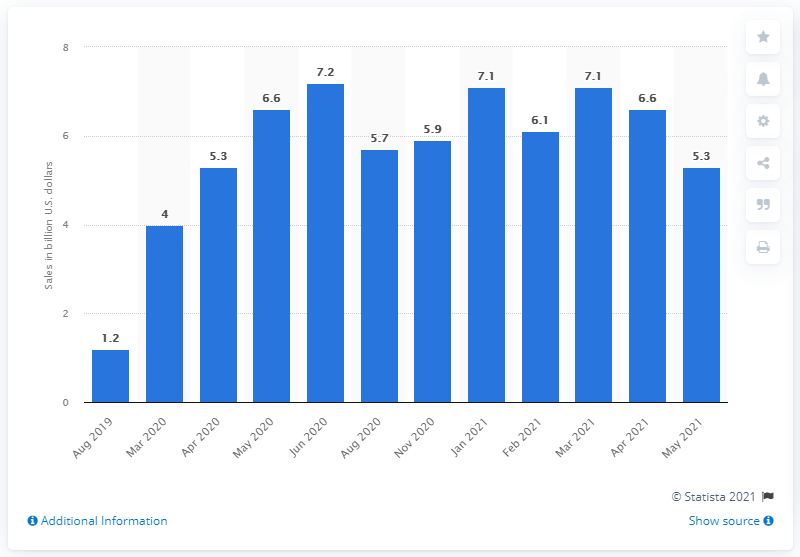List a handful of essential elements in this visual. As of May 2021, online grocery deliveries and in-store pickups had reached a significant milestone of 5.3. 